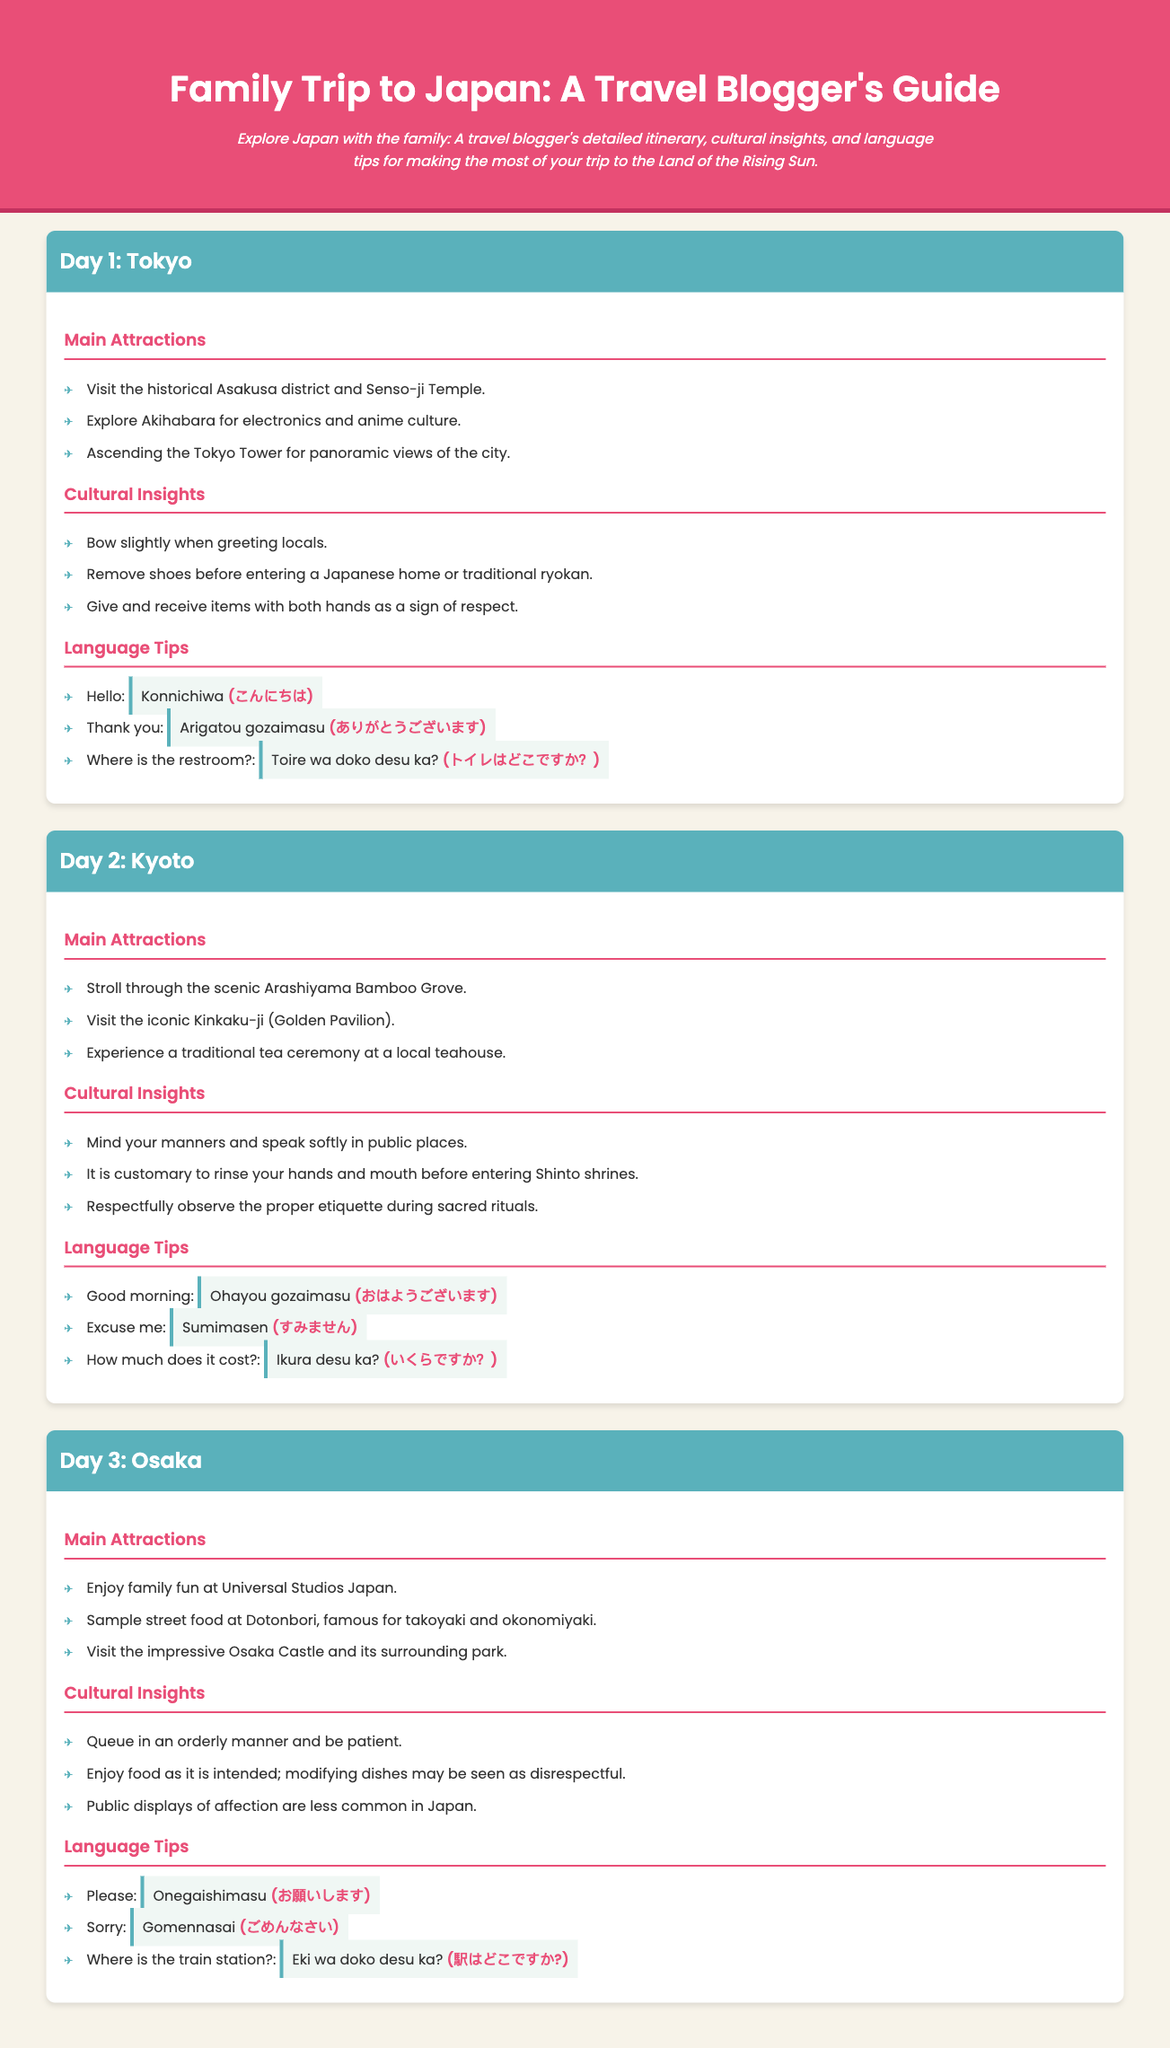What is the title of the document? The title of the document is presented in the header section of the webpage.
Answer: Family Trip to Japan: A Travel Blogger's Guide What is the first attraction listed for Tokyo? The first attraction for Tokyo is mentioned in the Day 1 section under Main Attractions.
Answer: Visit the historical Asakusa district and Senso-ji Temple What cultural insight is shared for Kyoto? The cultural insights for Kyoto are listed under the Day 2 section, and the first insight is noted.
Answer: Mind your manners and speak softly in public places What phrase means "Thank you" in Japanese? The language tips section in Day 1 provides phrases and their Japanese translations.
Answer: Arigatou gozaimasu How many days are covered in the itinerary? The itinerary is divided into three major sections, each representing a different day.
Answer: 3 What is one of the attractions to visit in Osaka? The attractions for Osaka are marked in the Day 3 section under Main Attractions.
Answer: Enjoy family fun at Universal Studios Japan What is a respectful gesture mentioned for greeting locals in Tokyo? The cultural insights in Day 1 highlight respectful gestures when interacting with locals.
Answer: Bow slightly when greeting locals What is the Japanese phrase for "Where is the restroom?" The specific phrases for asking about the restroom are listed under Language Tips in Day 1.
Answer: Toire wa doko desu ka? What type of document is this? This document serves as a travel guide summarizing key attractions, insights, and language tips for a family trip.
Answer: Travel guide 